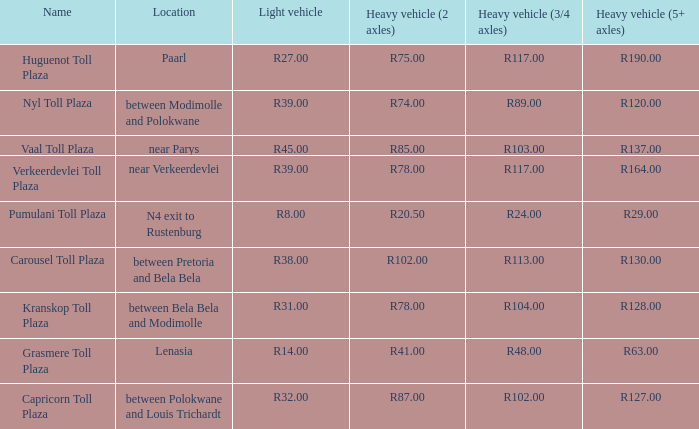What is the toll for light vehicles at the plaza between bela bela and modimolle? R31.00. 